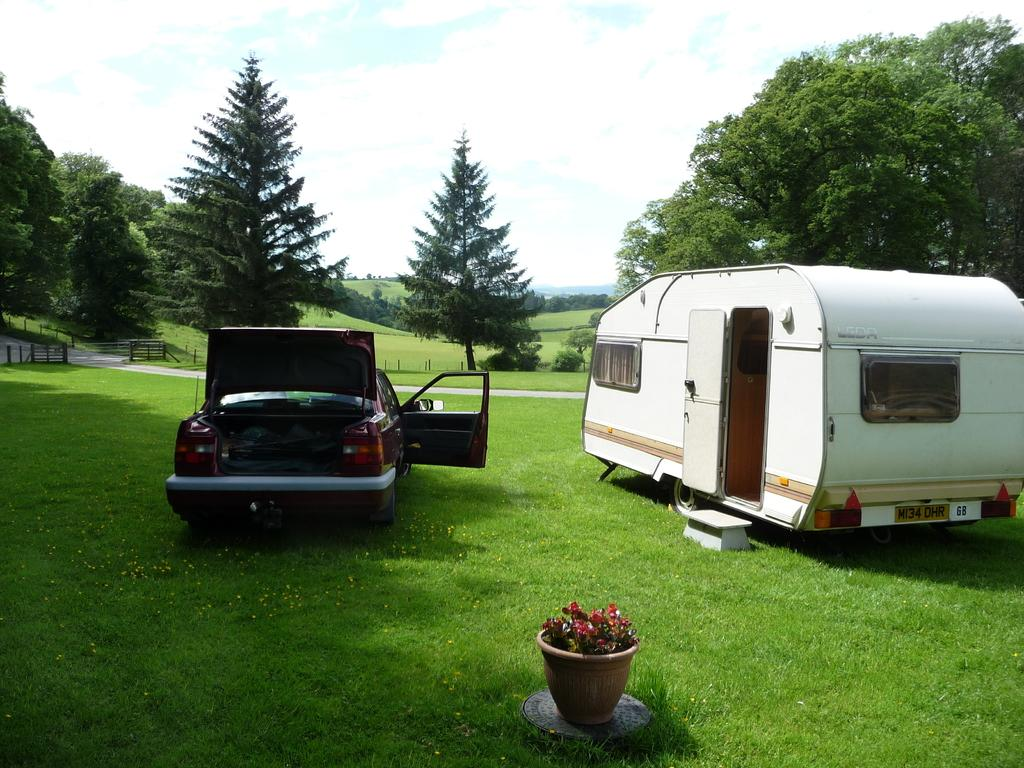What types of vehicles can be seen in the image? There are vehicles in the image, but the specific types are not mentioned. What is located near the vehicles in the image? There is a flower pot, trees, a fence, a road, and grass on the left side of the image. What can be seen in the background of the image? The sky is visible in the background of the image. What type of crime is being committed in the image? There is no indication of any crime being committed in the image. How does the friction between the vehicles and the road affect their movement in the image? The image does not show the vehicles in motion, so it is impossible to determine the effect of friction on their movement. 